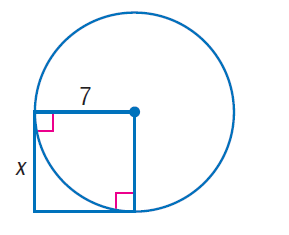Answer the mathemtical geometry problem and directly provide the correct option letter.
Question: Find x. Assume that segments that appear to be tangent are tangent.
Choices: A: \sqrt { 7 } B: 7 C: 7 \sqrt { 2 } D: 49 B 